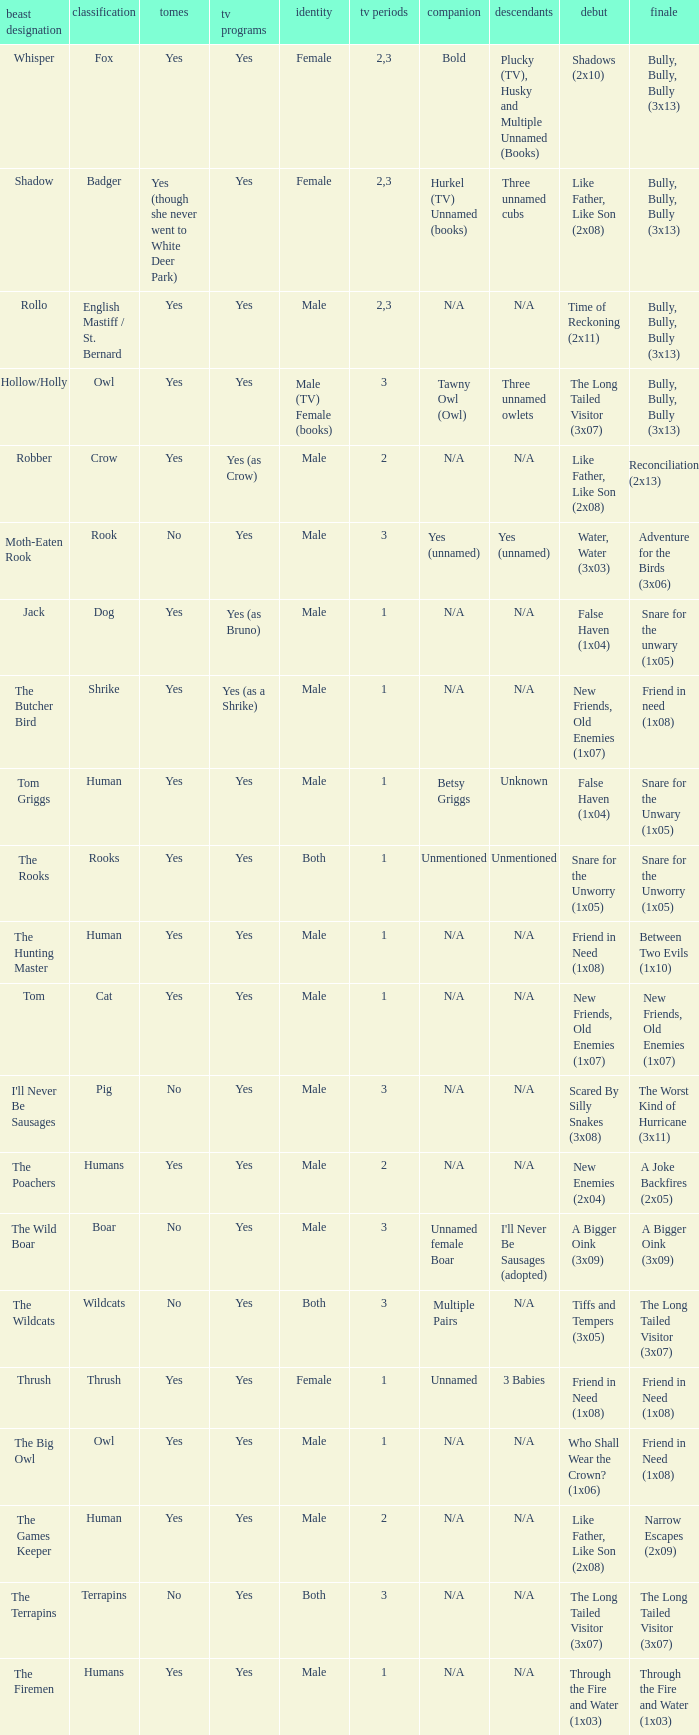What is the mate for Last Appearance of bully, bully, bully (3x13) for the animal named hollow/holly later than season 1? Tawny Owl (Owl). 